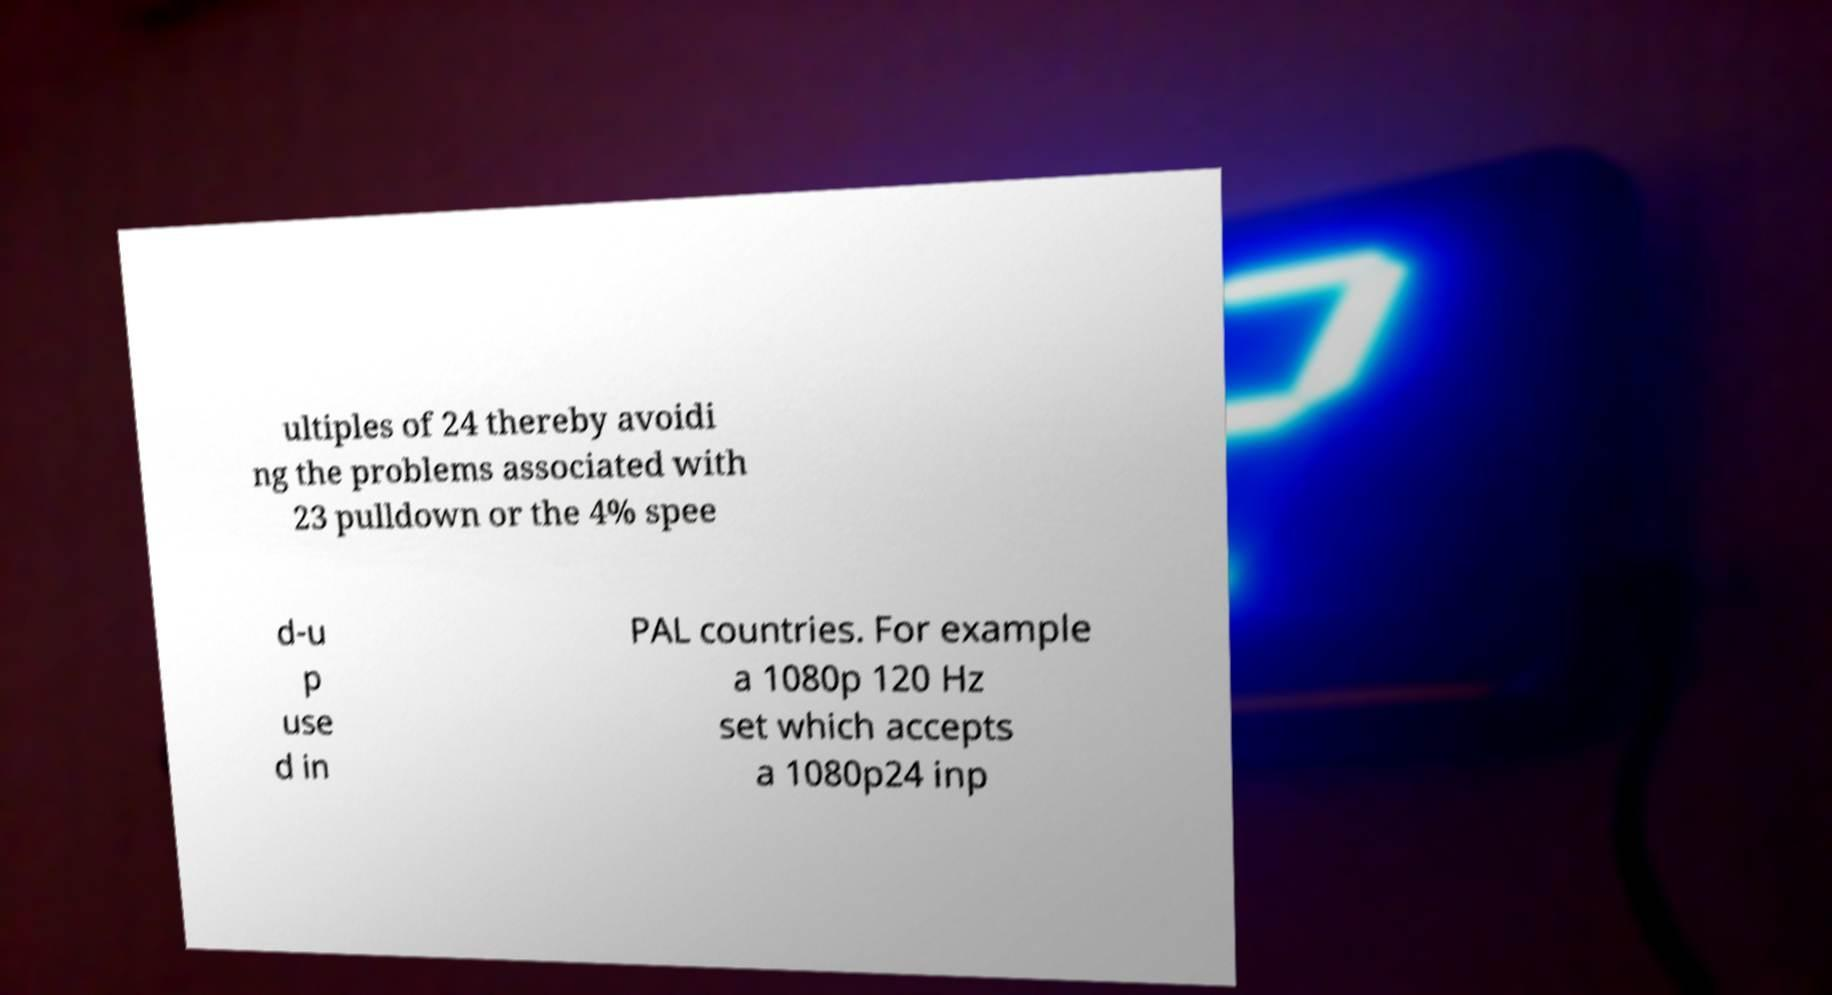Could you extract and type out the text from this image? ultiples of 24 thereby avoidi ng the problems associated with 23 pulldown or the 4% spee d-u p use d in PAL countries. For example a 1080p 120 Hz set which accepts a 1080p24 inp 